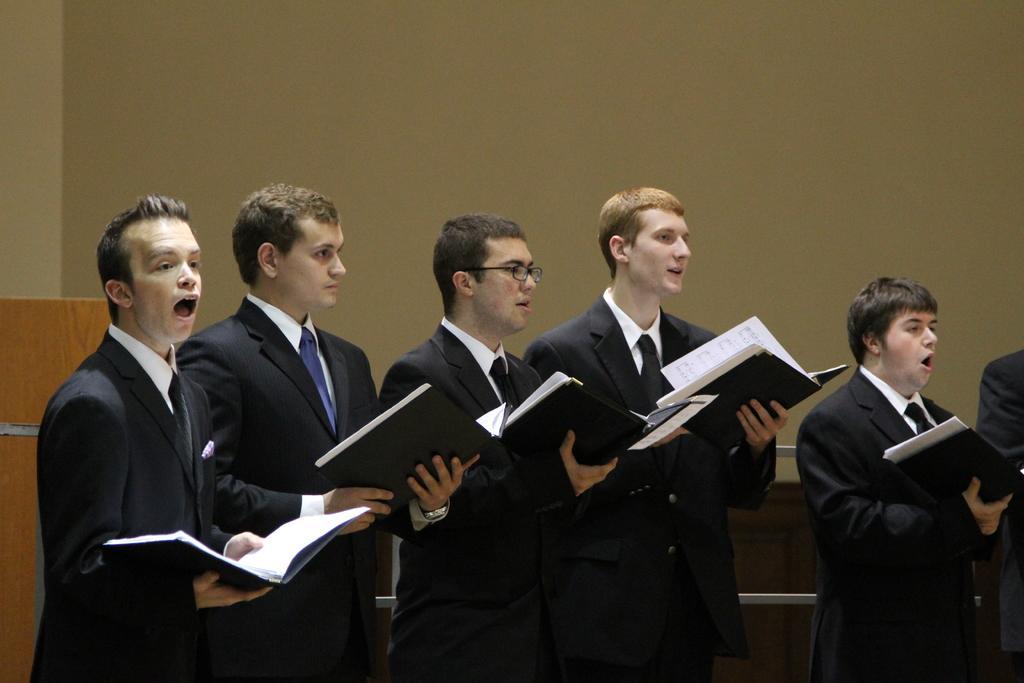Please provide a concise description of this image. In this picture I can see group of people standing and holding the books, it looks like a wooden object, and in the background there is a wall. 